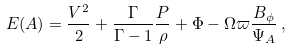<formula> <loc_0><loc_0><loc_500><loc_500>E ( A ) = \frac { V ^ { 2 } } { 2 } + \frac { \Gamma } { \Gamma - 1 } \frac { P } { \rho } + \Phi - \Omega \varpi \frac { B _ { \phi } } { \Psi _ { A } } \, ,</formula> 